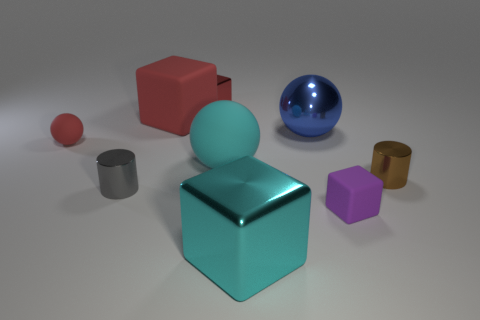What is the color of the large ball behind the big rubber object on the right side of the tiny red block behind the cyan metal object? blue 